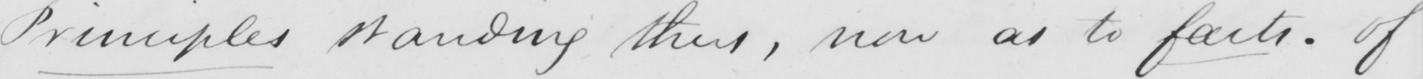Can you read and transcribe this handwriting? Principles standing thus , now as to facts . Of 